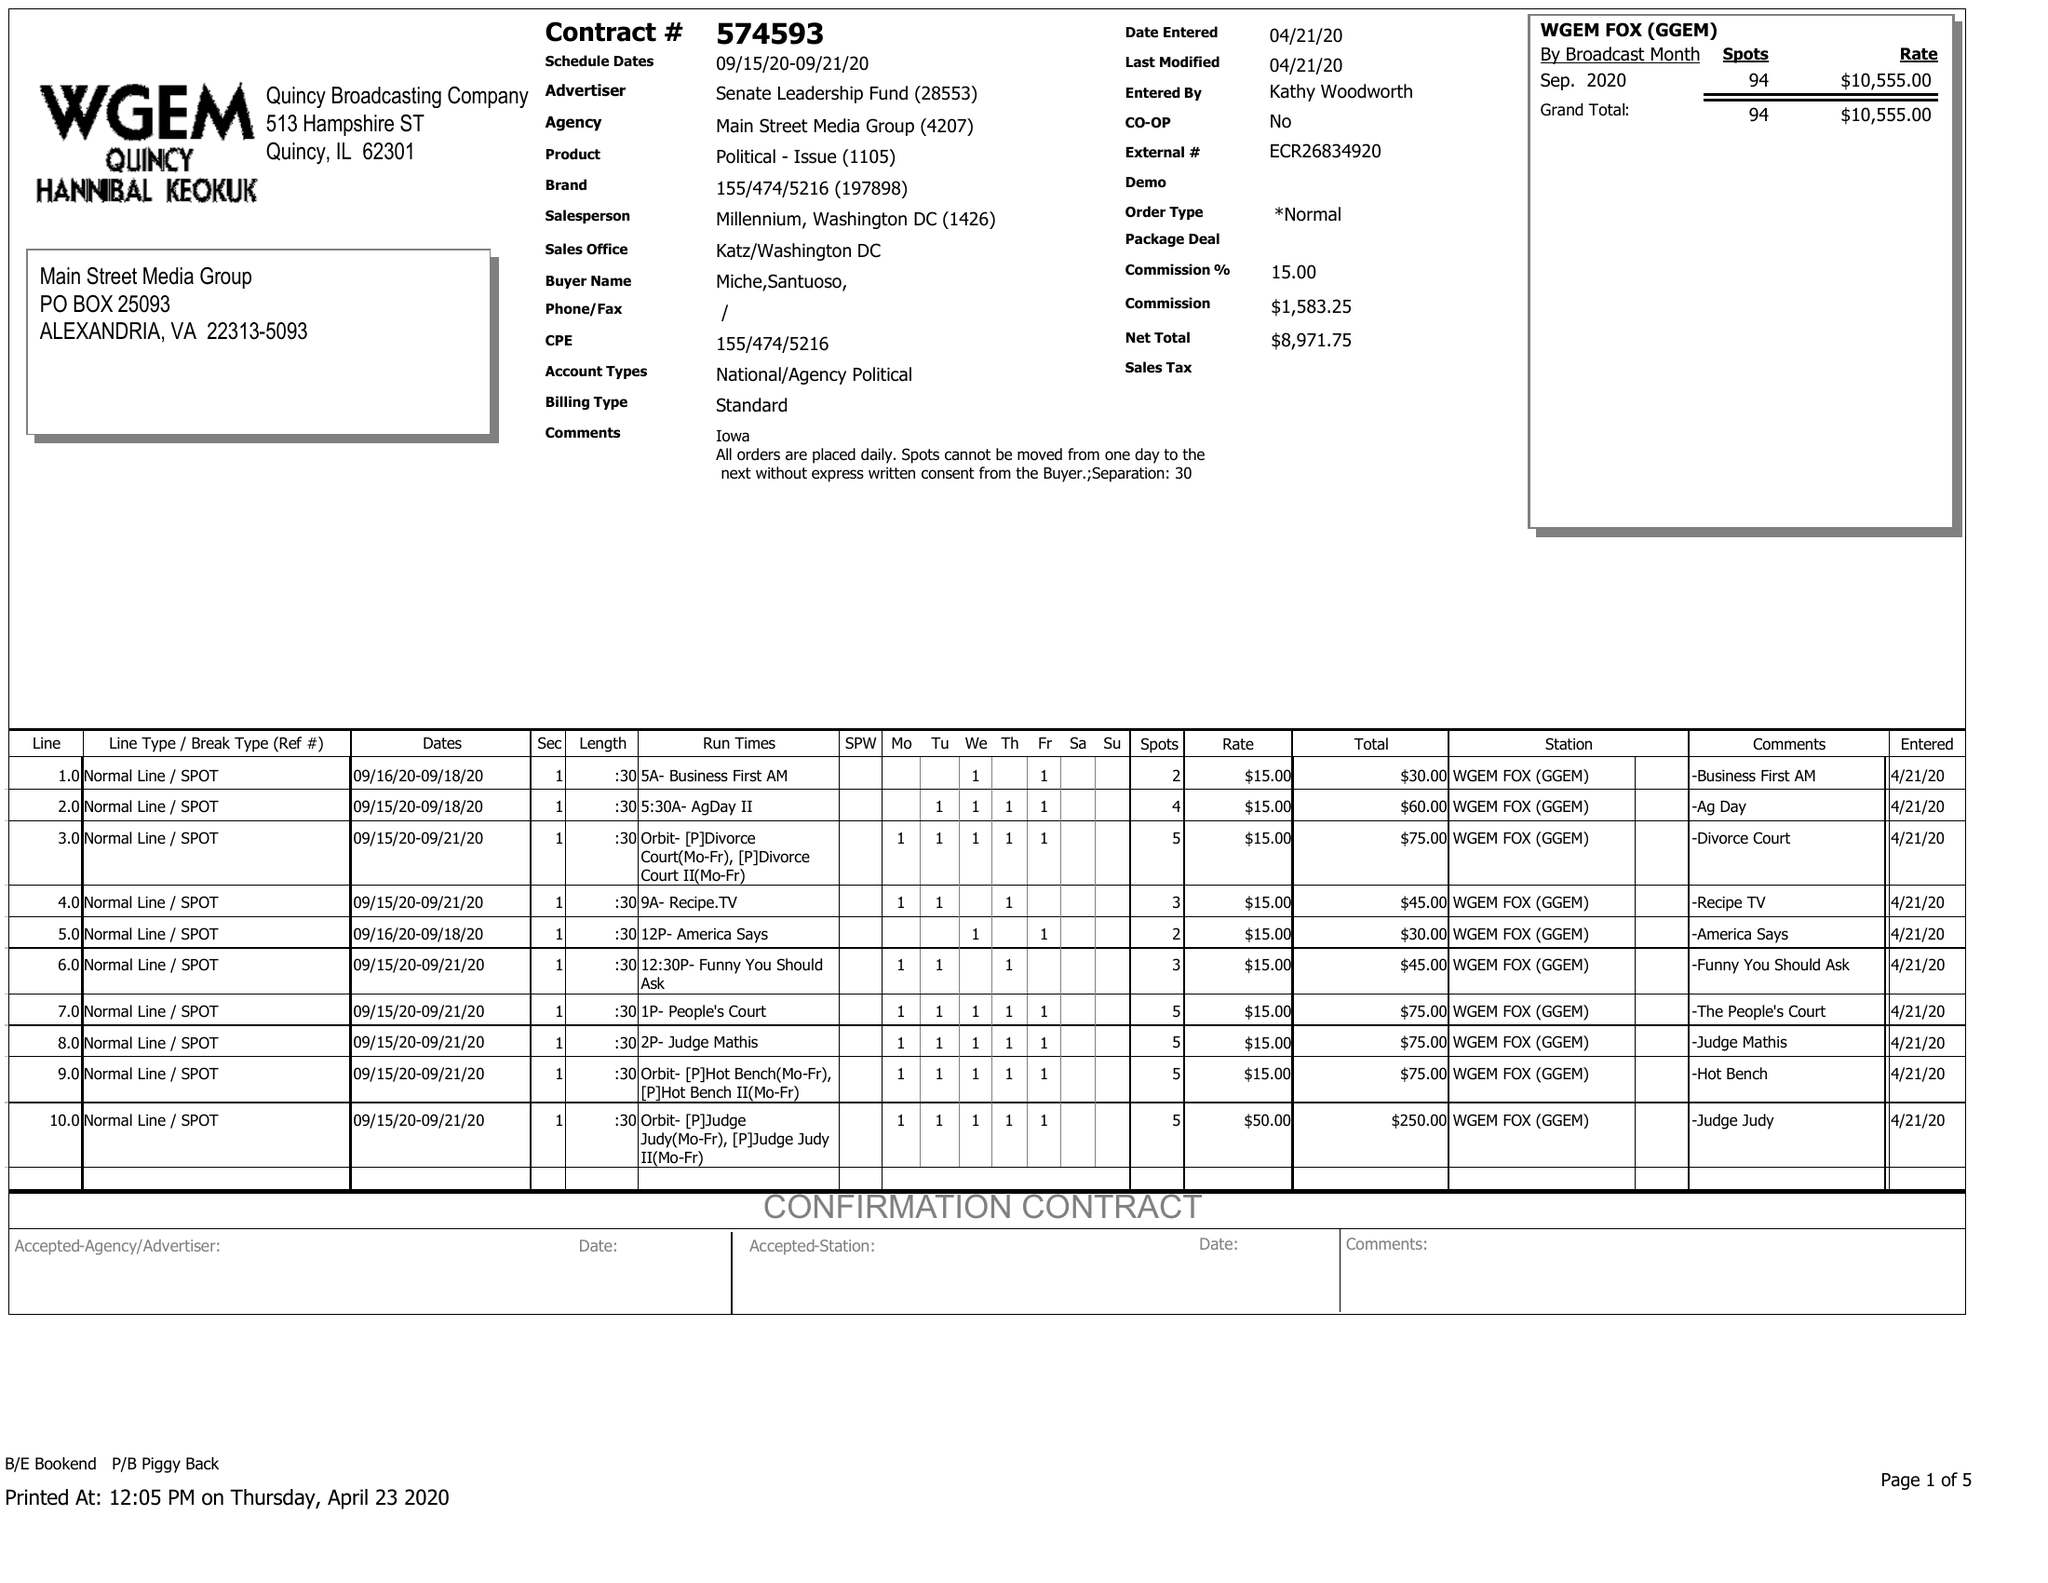What is the value for the flight_to?
Answer the question using a single word or phrase. 09/21/20 